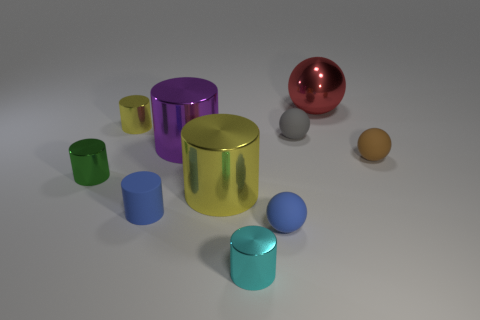What material is the yellow cylinder left of the blue rubber object left of the cyan cylinder made of?
Offer a terse response. Metal. Is there a large metallic sphere that has the same color as the rubber cylinder?
Your response must be concise. No. The matte cylinder that is the same size as the cyan object is what color?
Your response must be concise. Blue. What is the yellow thing left of the big cylinder behind the yellow metallic cylinder in front of the small yellow cylinder made of?
Your answer should be very brief. Metal. There is a small matte cylinder; is it the same color as the tiny matte ball on the left side of the tiny gray object?
Provide a succinct answer. Yes. How many objects are tiny cylinders that are behind the small gray ball or tiny balls to the left of the red metallic object?
Your response must be concise. 3. There is a blue thing in front of the tiny matte object that is on the left side of the big yellow shiny object; what is its shape?
Your answer should be compact. Sphere. Are there any tiny red things that have the same material as the tiny gray ball?
Your response must be concise. No. There is another large shiny thing that is the same shape as the purple shiny object; what color is it?
Give a very brief answer. Yellow. Is the number of purple things that are on the left side of the purple cylinder less than the number of small green metal things in front of the cyan thing?
Offer a terse response. No. 